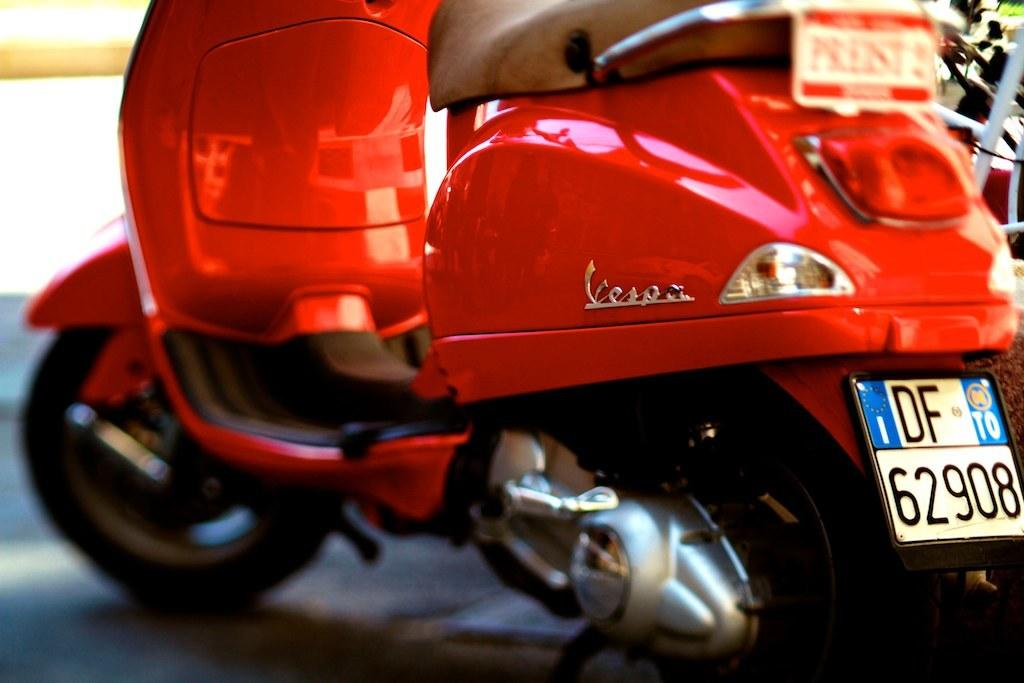What type of vehicle is in the image? There is a motorbike in the image. What colors can be seen on the motorbike? The motorbike is red and black in color. Where is the motorbike located in the image? The motorbike is on the ground. What else can be seen in the background of the image? There are other vehicles visible in the background of the image. What activity are the girls participating in with the flame in the image? There are no girls or flames present in the image. 